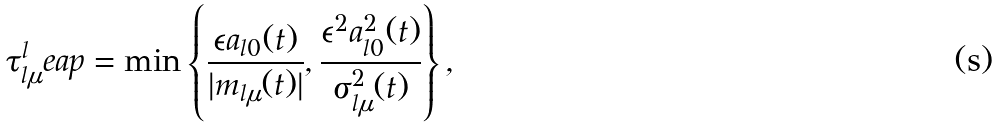Convert formula to latex. <formula><loc_0><loc_0><loc_500><loc_500>\tau _ { l \mu } ^ { l } e a p = \min \left \{ \frac { \epsilon a _ { l 0 } ( t ) } { | m _ { l \mu } ( t ) | } , \frac { \epsilon ^ { 2 } a _ { l 0 } ^ { 2 } ( t ) } { \sigma _ { l \mu } ^ { 2 } ( t ) } \right \} ,</formula> 